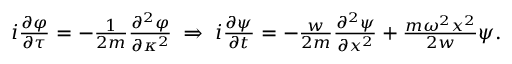Convert formula to latex. <formula><loc_0><loc_0><loc_500><loc_500>\begin{array} { r } { i \frac { \partial \varphi } { \partial \tau } = - \frac { 1 } { 2 m } \frac { \partial ^ { 2 } \varphi } { \partial \kappa ^ { 2 } } \, \Rightarrow \, i \frac { \partial \psi } { \partial t } = - \frac { w } { 2 m } \frac { \partial ^ { 2 } \psi } { \partial x ^ { 2 } } + \frac { m \omega ^ { 2 } x ^ { 2 } } { 2 w } \psi . } \end{array}</formula> 